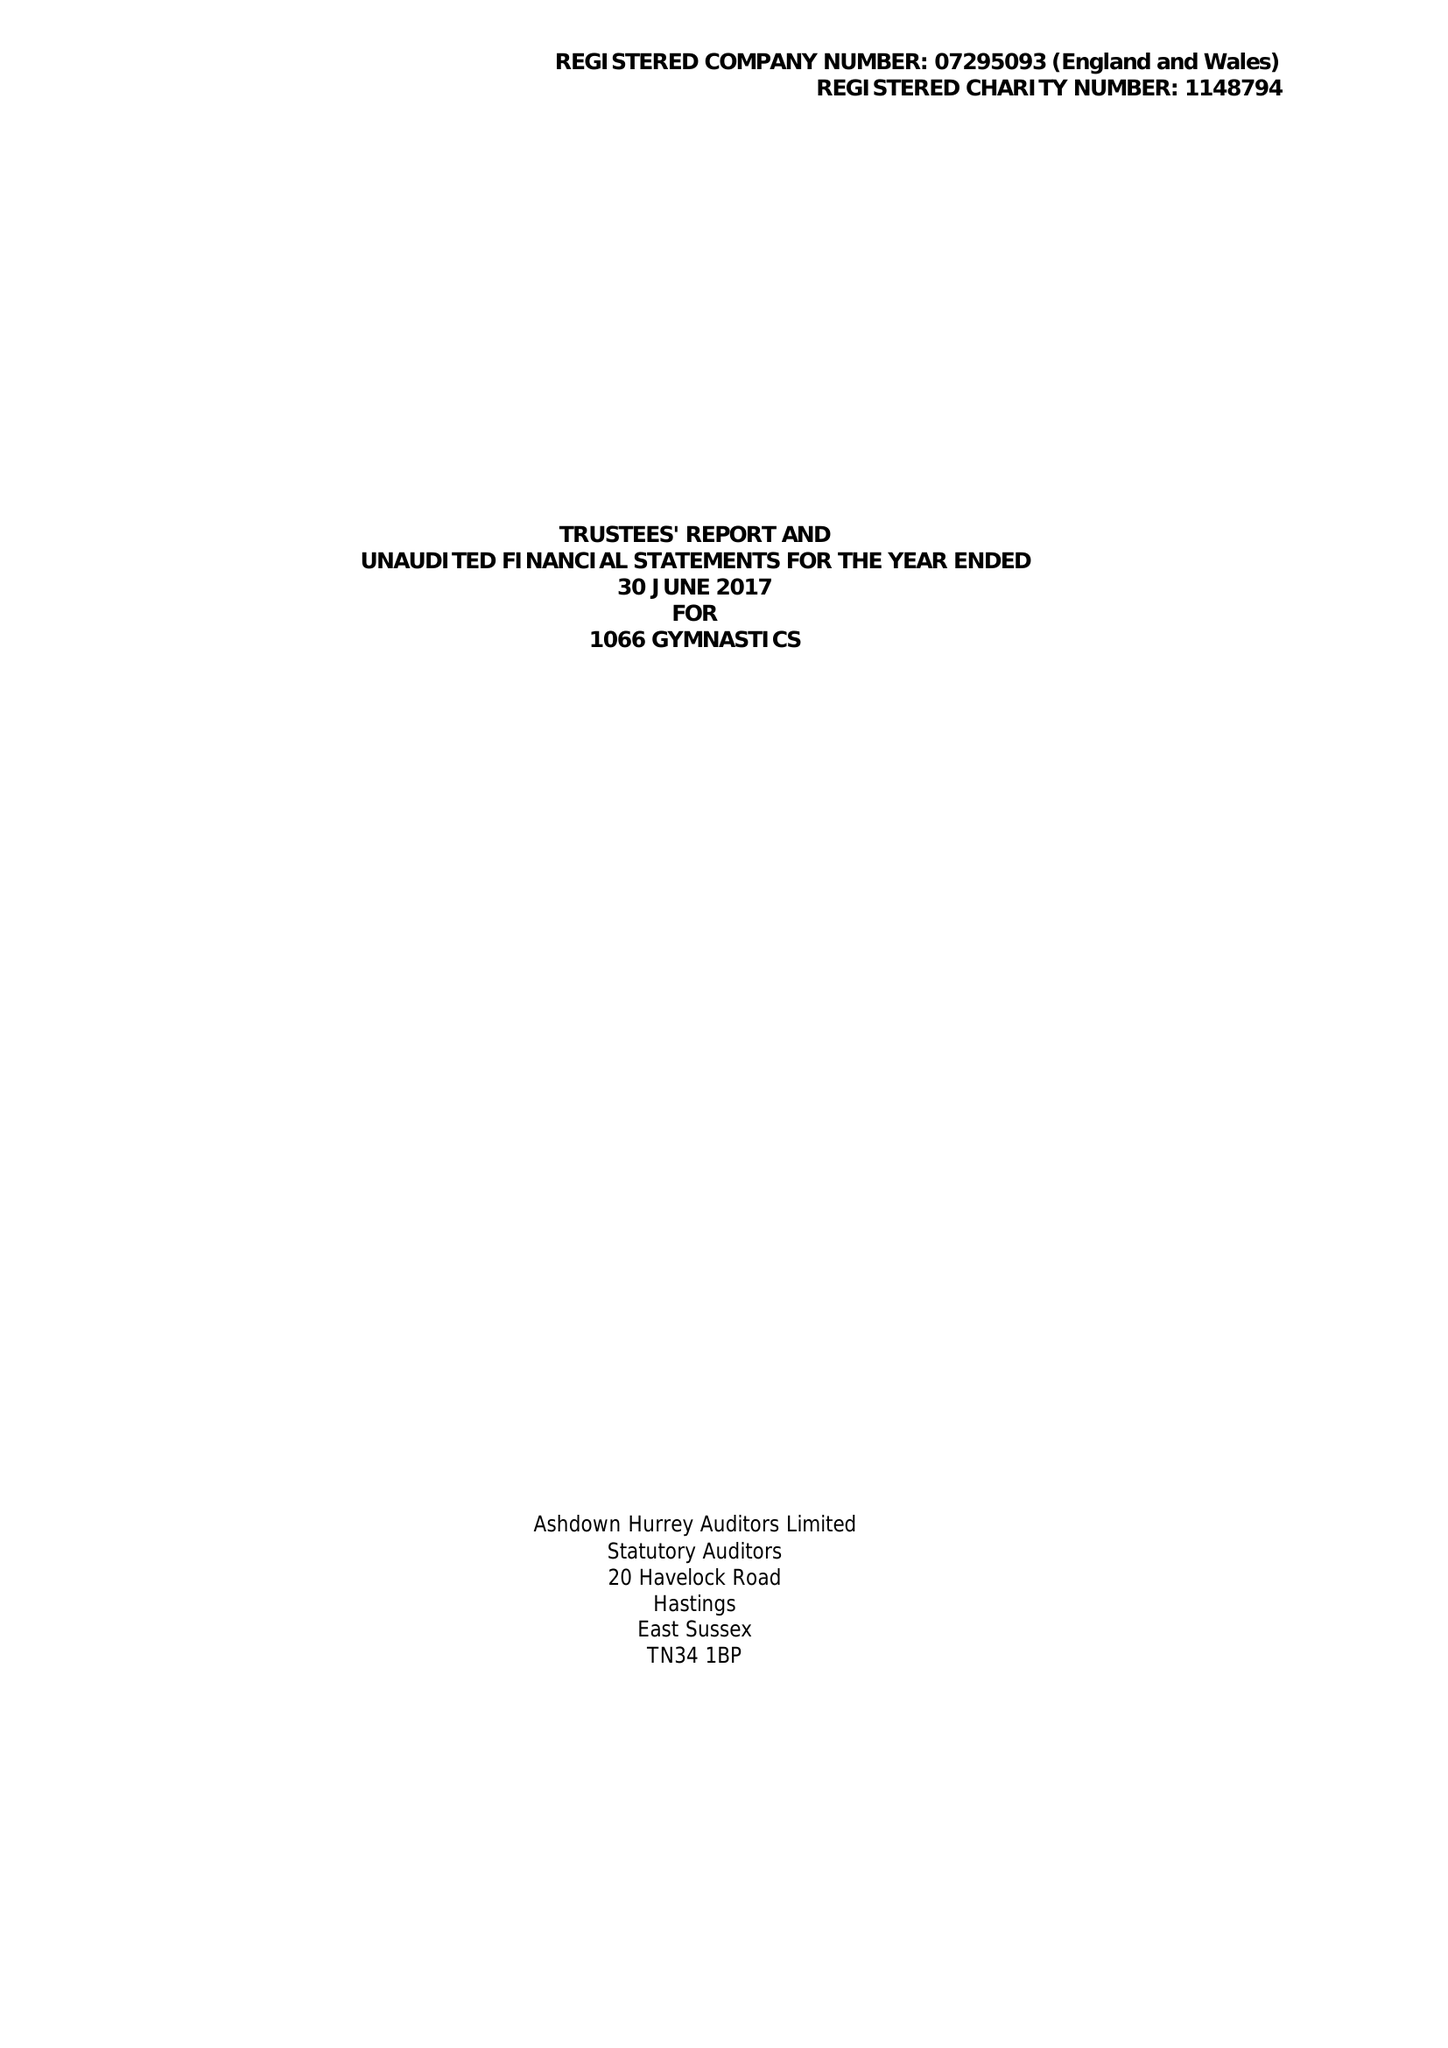What is the value for the address__street_line?
Answer the question using a single word or phrase. 3A BRETT DRIVE 